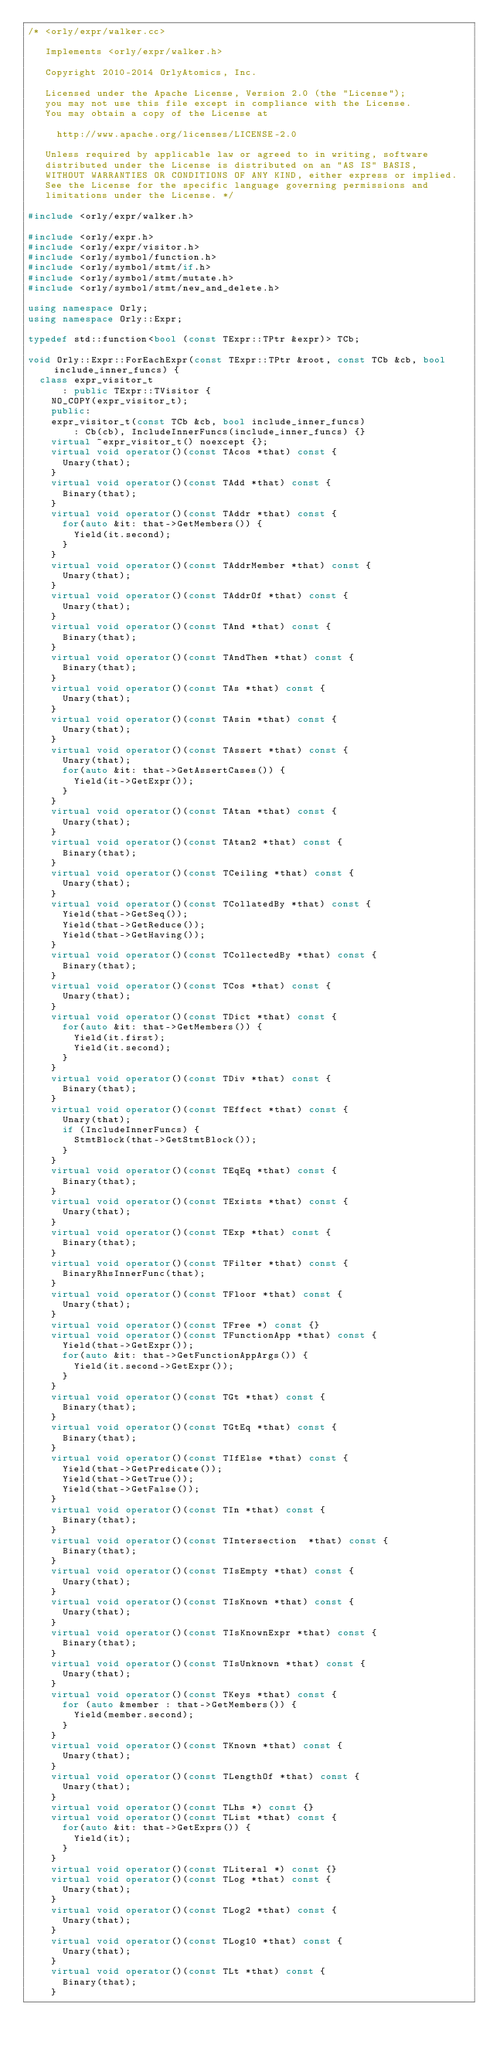<code> <loc_0><loc_0><loc_500><loc_500><_C++_>/* <orly/expr/walker.cc>

   Implements <orly/expr/walker.h>

   Copyright 2010-2014 OrlyAtomics, Inc.

   Licensed under the Apache License, Version 2.0 (the "License");
   you may not use this file except in compliance with the License.
   You may obtain a copy of the License at

     http://www.apache.org/licenses/LICENSE-2.0

   Unless required by applicable law or agreed to in writing, software
   distributed under the License is distributed on an "AS IS" BASIS,
   WITHOUT WARRANTIES OR CONDITIONS OF ANY KIND, either express or implied.
   See the License for the specific language governing permissions and
   limitations under the License. */

#include <orly/expr/walker.h>

#include <orly/expr.h>
#include <orly/expr/visitor.h>
#include <orly/symbol/function.h>
#include <orly/symbol/stmt/if.h>
#include <orly/symbol/stmt/mutate.h>
#include <orly/symbol/stmt/new_and_delete.h>

using namespace Orly;
using namespace Orly::Expr;

typedef std::function<bool (const TExpr::TPtr &expr)> TCb;

void Orly::Expr::ForEachExpr(const TExpr::TPtr &root, const TCb &cb, bool include_inner_funcs) {
  class expr_visitor_t
      : public TExpr::TVisitor {
    NO_COPY(expr_visitor_t);
    public:
    expr_visitor_t(const TCb &cb, bool include_inner_funcs)
        : Cb(cb), IncludeInnerFuncs(include_inner_funcs) {}
    virtual ~expr_visitor_t() noexcept {};
    virtual void operator()(const TAcos *that) const {
      Unary(that);
    }
    virtual void operator()(const TAdd *that) const {
      Binary(that);
    }
    virtual void operator()(const TAddr *that) const {
      for(auto &it: that->GetMembers()) {
        Yield(it.second);
      }
    }
    virtual void operator()(const TAddrMember *that) const {
      Unary(that);
    }
    virtual void operator()(const TAddrOf *that) const {
      Unary(that);
    }
    virtual void operator()(const TAnd *that) const {
      Binary(that);
    }
    virtual void operator()(const TAndThen *that) const {
      Binary(that);
    }
    virtual void operator()(const TAs *that) const {
      Unary(that);
    }
    virtual void operator()(const TAsin *that) const {
      Unary(that);
    }
    virtual void operator()(const TAssert *that) const {
      Unary(that);
      for(auto &it: that->GetAssertCases()) {
        Yield(it->GetExpr());
      }
    }
    virtual void operator()(const TAtan *that) const {
      Unary(that);
    }
    virtual void operator()(const TAtan2 *that) const {
      Binary(that);
    }
    virtual void operator()(const TCeiling *that) const {
      Unary(that);
    }
    virtual void operator()(const TCollatedBy *that) const {
      Yield(that->GetSeq());
      Yield(that->GetReduce());
      Yield(that->GetHaving());
    }
    virtual void operator()(const TCollectedBy *that) const {
      Binary(that);
    }
    virtual void operator()(const TCos *that) const {
      Unary(that);
    }
    virtual void operator()(const TDict *that) const {
      for(auto &it: that->GetMembers()) {
        Yield(it.first);
        Yield(it.second);
      }
    }
    virtual void operator()(const TDiv *that) const {
      Binary(that);
    }
    virtual void operator()(const TEffect *that) const {
      Unary(that);
      if (IncludeInnerFuncs) {
        StmtBlock(that->GetStmtBlock());
      }
    }
    virtual void operator()(const TEqEq *that) const {
      Binary(that);
    }
    virtual void operator()(const TExists *that) const {
      Unary(that);
    }
    virtual void operator()(const TExp *that) const {
      Binary(that);
    }
    virtual void operator()(const TFilter *that) const {
      BinaryRhsInnerFunc(that);
    }
    virtual void operator()(const TFloor *that) const {
      Unary(that);
    }
    virtual void operator()(const TFree *) const {}
    virtual void operator()(const TFunctionApp *that) const {
      Yield(that->GetExpr());
      for(auto &it: that->GetFunctionAppArgs()) {
        Yield(it.second->GetExpr());
      }
    }
    virtual void operator()(const TGt *that) const {
      Binary(that);
    }
    virtual void operator()(const TGtEq *that) const {
      Binary(that);
    }
    virtual void operator()(const TIfElse *that) const {
      Yield(that->GetPredicate());
      Yield(that->GetTrue());
      Yield(that->GetFalse());
    }
    virtual void operator()(const TIn *that) const {
      Binary(that);
    }
    virtual void operator()(const TIntersection  *that) const {
      Binary(that);
    }
    virtual void operator()(const TIsEmpty *that) const {
      Unary(that);
    }
    virtual void operator()(const TIsKnown *that) const {
      Unary(that);
    }
    virtual void operator()(const TIsKnownExpr *that) const {
      Binary(that);
    }
    virtual void operator()(const TIsUnknown *that) const {
      Unary(that);
    }
    virtual void operator()(const TKeys *that) const {
      for (auto &member : that->GetMembers()) {
        Yield(member.second);
      }
    }
    virtual void operator()(const TKnown *that) const {
      Unary(that);
    }
    virtual void operator()(const TLengthOf *that) const {
      Unary(that);
    }
    virtual void operator()(const TLhs *) const {}
    virtual void operator()(const TList *that) const {
      for(auto &it: that->GetExprs()) {
        Yield(it);
      }
    }
    virtual void operator()(const TLiteral *) const {}
    virtual void operator()(const TLog *that) const {
      Unary(that);
    }
    virtual void operator()(const TLog2 *that) const {
      Unary(that);
    }
    virtual void operator()(const TLog10 *that) const {
      Unary(that);
    }
    virtual void operator()(const TLt *that) const {
      Binary(that);
    }</code> 